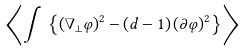Convert formula to latex. <formula><loc_0><loc_0><loc_500><loc_500>\left \langle \int \, \left \{ \left ( \nabla _ { \bot } \varphi \right ) ^ { 2 } - \left ( d - 1 \right ) \left ( \partial \varphi \right ) ^ { 2 } \right \} \right \rangle</formula> 